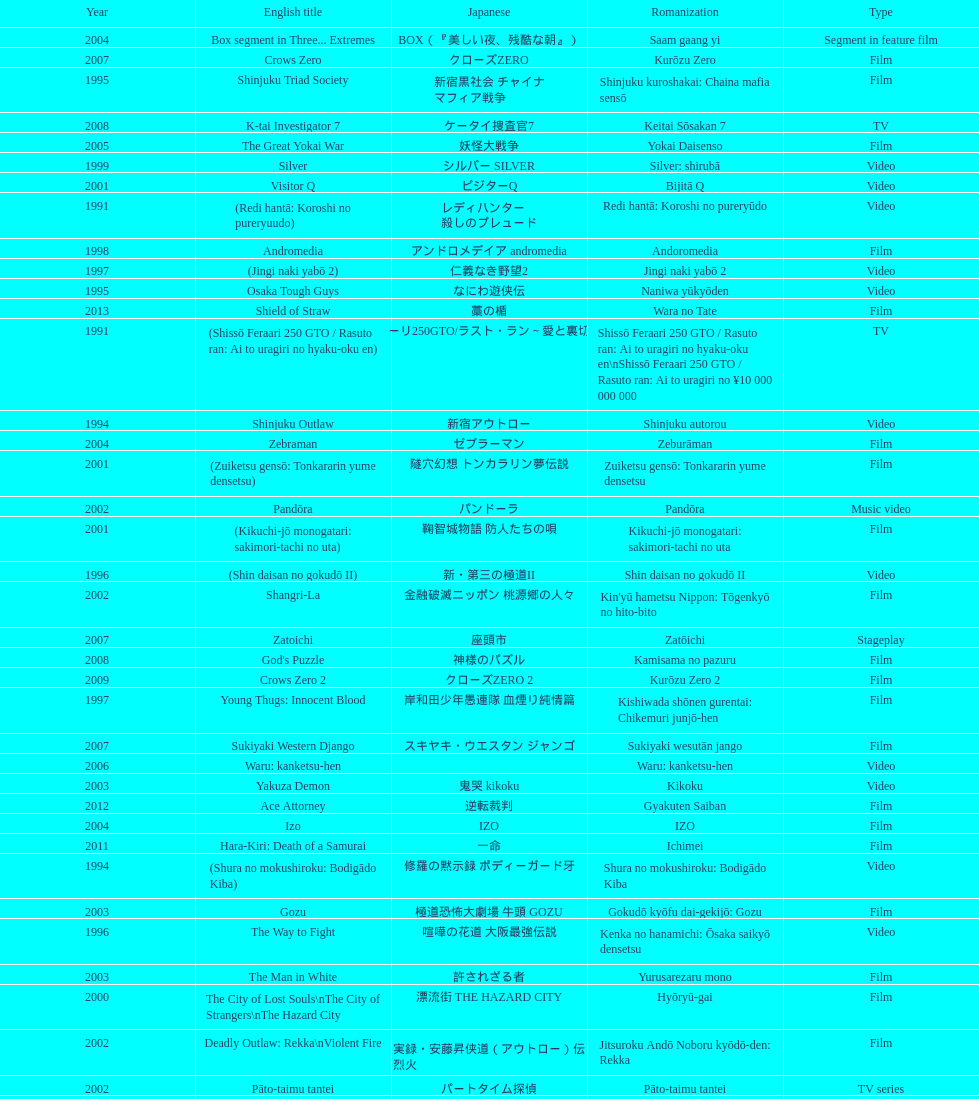What is takashi miike's work with the least amount of years since release? The Mole Song: Undercover Agent Reiji. 